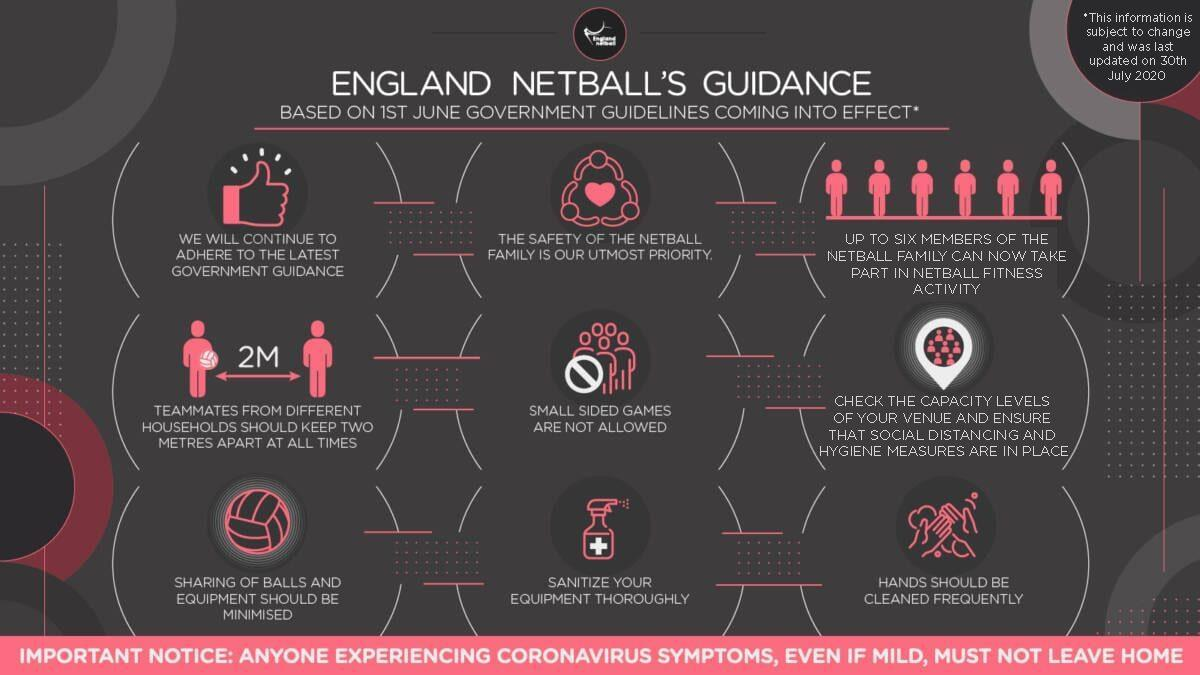What should be adhered to?
Answer the question with a short phrase. the latest government guidance Maximum how many members can take part in fitness activity? up to six what should be thoroughly sanitized? your equipment What has to be cleaned frequently? hands What are not allowed as per latest guidance? small sided games 